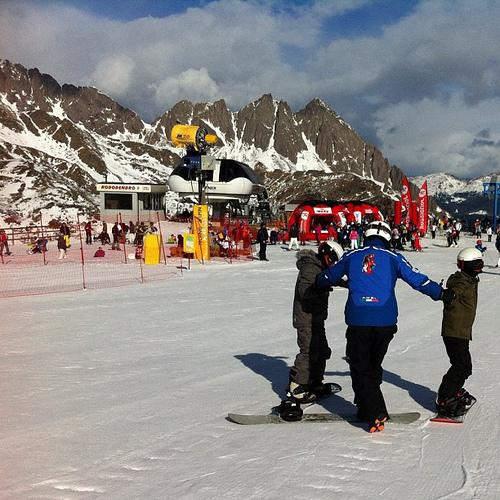Assess the quality of the image based on the objects and their clarity. While specific details like logos and shoe bottoms can be seen, the quality of the image is still moderate, as the clarity of the people and other objects vary. What type of clothing and gear are the people in this image wearing? A blue and white coat, a blue jacket with a logo, a white helmet, black pants, tennis shoes with orange bottoms, and snowsuits. What is the sentiment or mood of the image? The image displays an active and adventurous mood, with people enjoying winter sports amidst a snowy, mountainous landscape. What kind of reasoning is needed to understand the relationships between the objects in this scene? Complex reasoning is needed to understand how the people, their clothing, equipment, and the natural landscape interact during the winter sports. What are some striking features of the landscape in this image? There are jagged, snowy mountain tops, rocks with snow on them, huge and jagged rocks, and tracks in the snow. How many distinct individuals are involved in snow sports? There are at least five people participating in snow sports - one boy on a snowboard, one boy on skis, and three other individuals. Describe the objects and their interactions with each other. People are skiing and snowboarding near the red fencing by the ski lift, wearing various clothing and gear, casting a shadow on the snow. The snowy landscape and rocks provide challenges for them to navigate. What are the weather conditions like in this image? The weather is cloudy with gray clouds in the sky, and it is snowing at a resort during the winter season. How would you describe the scene unfolding at the area with people? People are skiing and snowboarding, with some wearing helmets, snowsuits, and jackets. There are boys on snowboards and skis and a man without any equipment. There's a shadow of a skier. Can you identify any specific sport-related objects in the scene? List them down. Snowboard, snow skis, helmet, tennis shoes, ski lift pylon, and red fencing near the ski lift. 